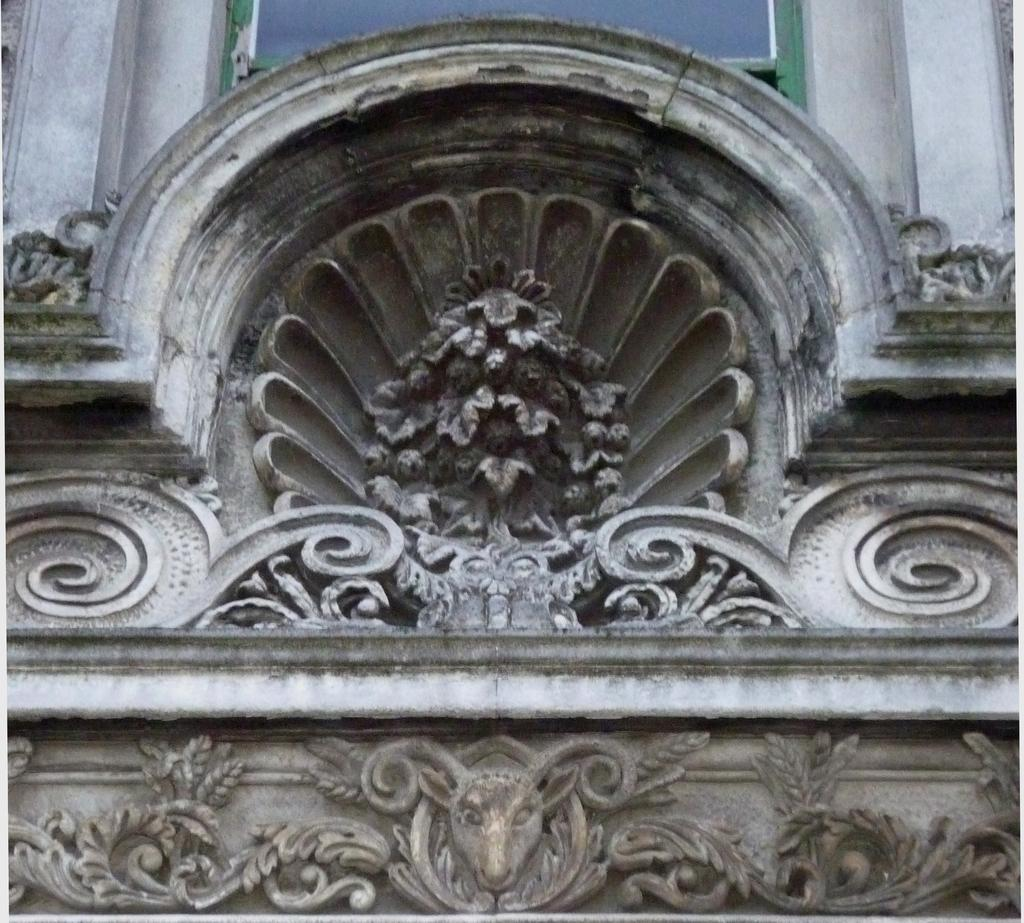What type of structure can be seen in the image? There is an arch in the image. What other architectural element is present in the image? There is a wall in the image. What theory is being discussed by the band in the image? There is no band or discussion of a theory present in the image; it only features an arch and a wall. 